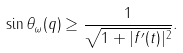Convert formula to latex. <formula><loc_0><loc_0><loc_500><loc_500>\sin \theta _ { \omega } ( q ) \geq \frac { 1 } { \sqrt { 1 + | f ^ { \prime } ( t ) | ^ { 2 } } } .</formula> 